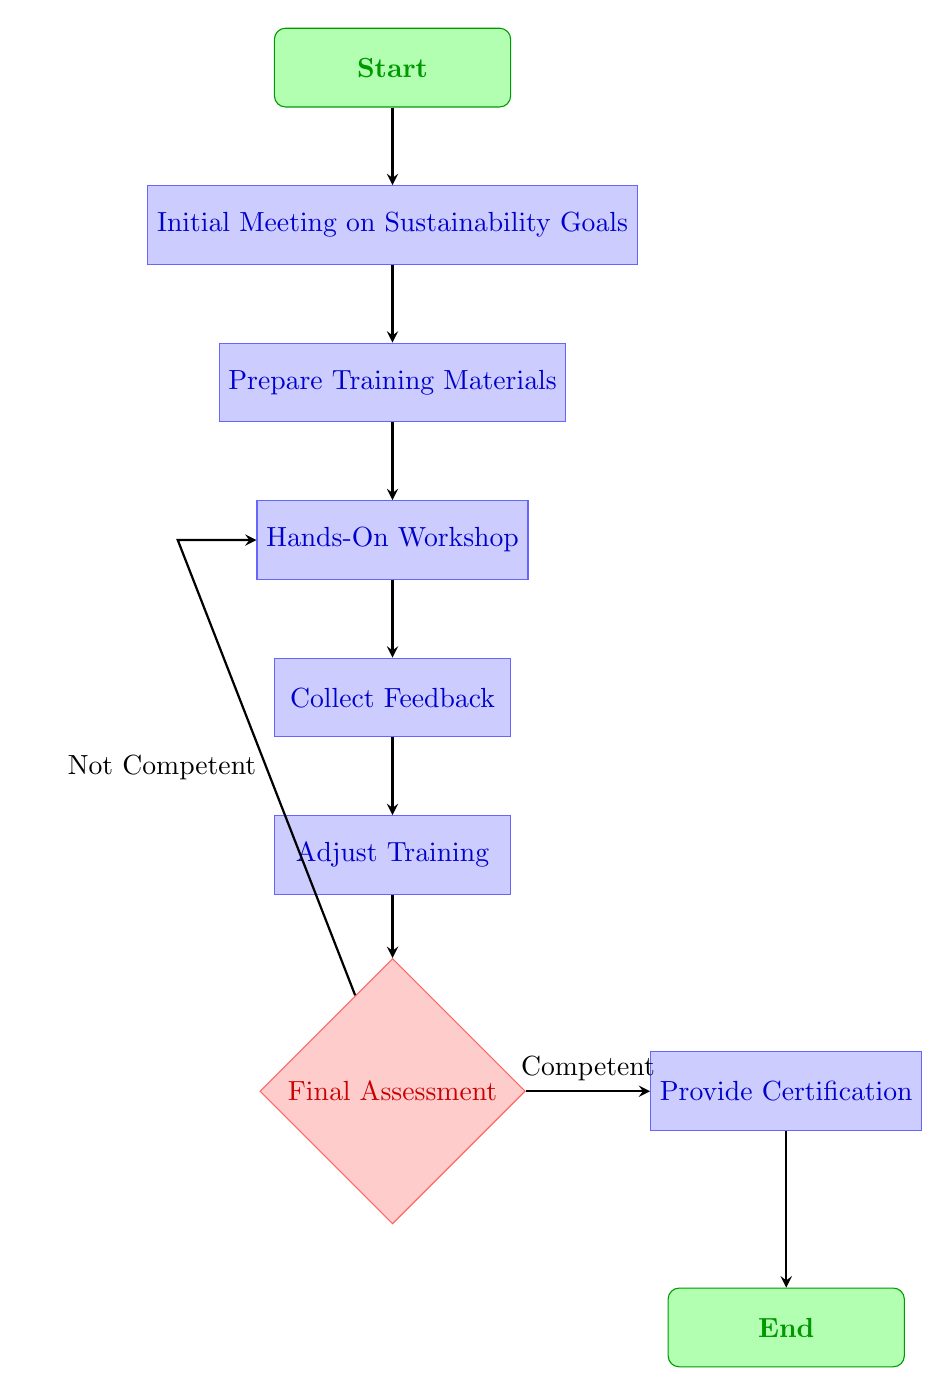What is the first node in the diagram? The first node in the diagram is the "Start" node, indicating the beginning of the employee training process.
Answer: Start How many process nodes are there in the flow chart? There are five process nodes in the flow chart: "Initial Meeting on Sustainability Goals," "Prepare Training Materials," "Hands-On Workshop," "Collect Feedback," and "Adjust Training."
Answer: 5 What action follows the "Hands-On Workshop"? The action that follows the "Hands-On Workshop" is to "Collect Feedback from Employees." This is a sequential step following the workshop.
Answer: Collect Feedback from Employees What decision is made after "Adjust Training"? The decision made after "Adjust Training" is the "Final Assessment of Employee Competence." This decision determines whether employees are competent enough to proceed.
Answer: Final Assessment of Employee Competence What happens if an employee is found to be "Not Competent"? If an employee is found to be "Not Competent," they will return to the "Hands-On Workshop" for additional training. This loop allows for further practice before reassessment.
Answer: Hands-On Workshop Which node comes before "Provide Certification of Completion"? The node that comes before "Provide Certification of Completion" is the "Final Assessment of Employee Competence," which determines if certification can be awarded.
Answer: Final Assessment of Employee Competence 